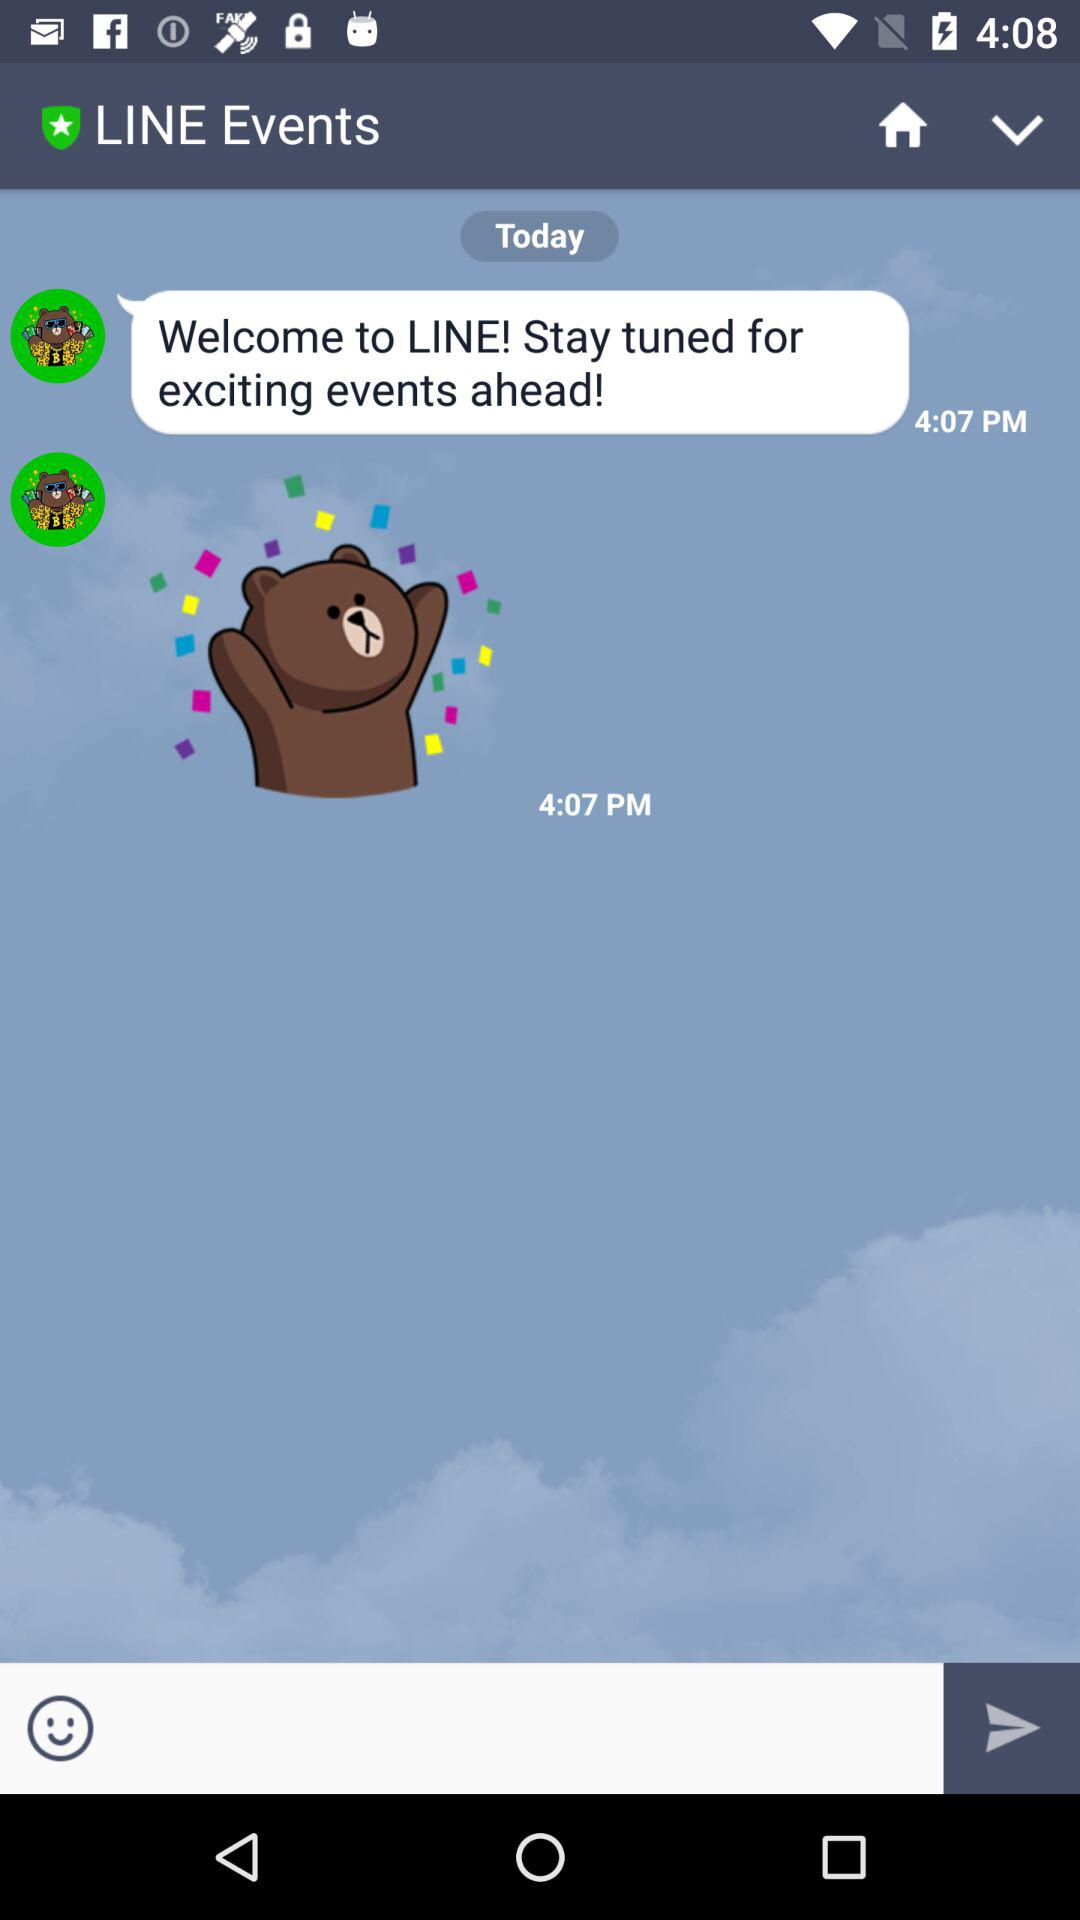What is the application name? The application name is LINE. 